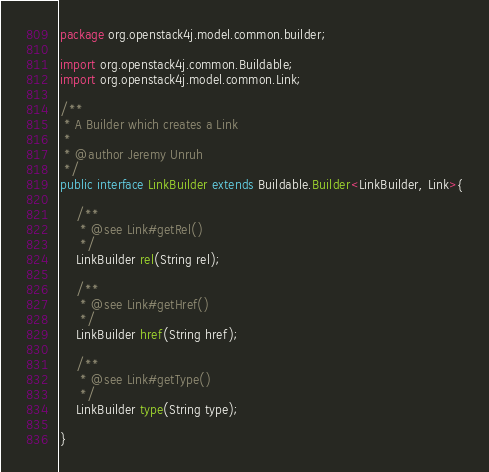Convert code to text. <code><loc_0><loc_0><loc_500><loc_500><_Java_>package org.openstack4j.model.common.builder;

import org.openstack4j.common.Buildable;
import org.openstack4j.model.common.Link;

/**
 * A Builder which creates a Link
 * 
 * @author Jeremy Unruh
 */
public interface LinkBuilder extends Buildable.Builder<LinkBuilder, Link>{

	/**
	 * @see Link#getRel()
	 */
	LinkBuilder rel(String rel);
	
	/**
	 * @see Link#getHref()
	 */
	LinkBuilder href(String href);
	
	/**
	 * @see Link#getType()
	 */
	LinkBuilder type(String type);
	
}
</code> 